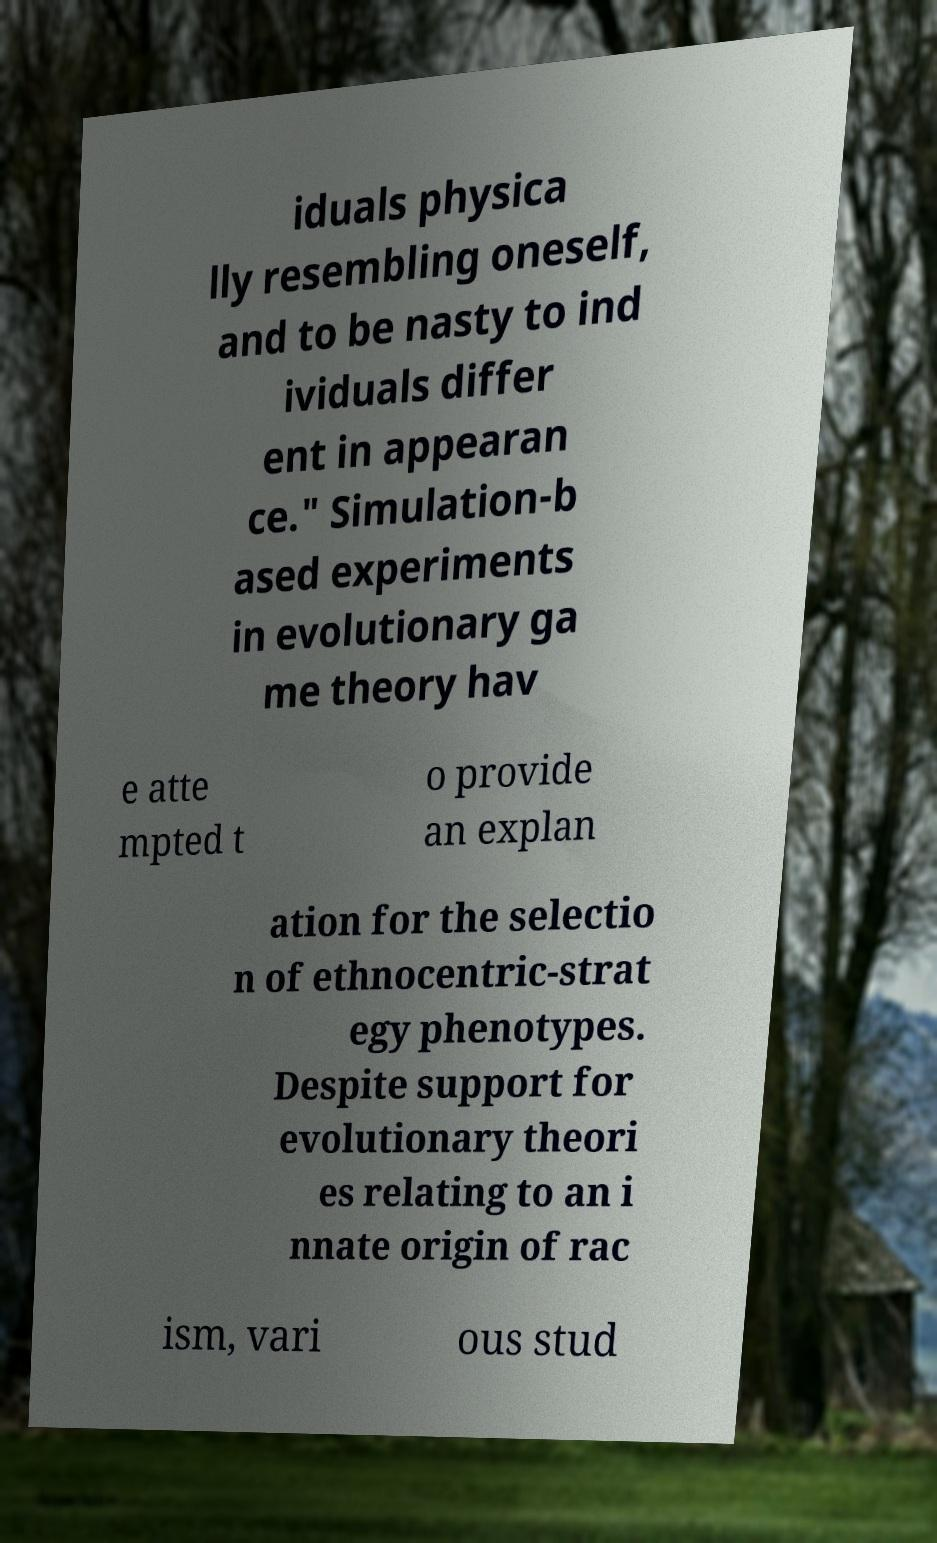For documentation purposes, I need the text within this image transcribed. Could you provide that? iduals physica lly resembling oneself, and to be nasty to ind ividuals differ ent in appearan ce." Simulation-b ased experiments in evolutionary ga me theory hav e atte mpted t o provide an explan ation for the selectio n of ethnocentric-strat egy phenotypes. Despite support for evolutionary theori es relating to an i nnate origin of rac ism, vari ous stud 